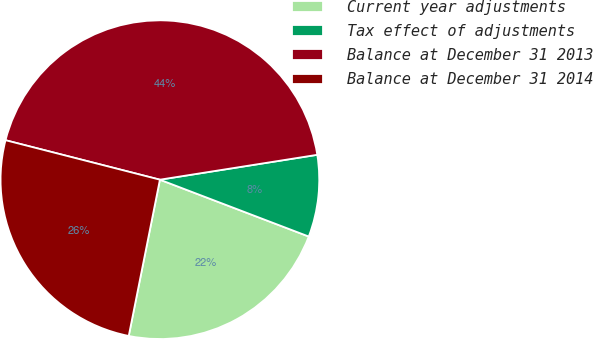Convert chart to OTSL. <chart><loc_0><loc_0><loc_500><loc_500><pie_chart><fcel>Current year adjustments<fcel>Tax effect of adjustments<fcel>Balance at December 31 2013<fcel>Balance at December 31 2014<nl><fcel>22.33%<fcel>8.3%<fcel>43.52%<fcel>25.85%<nl></chart> 